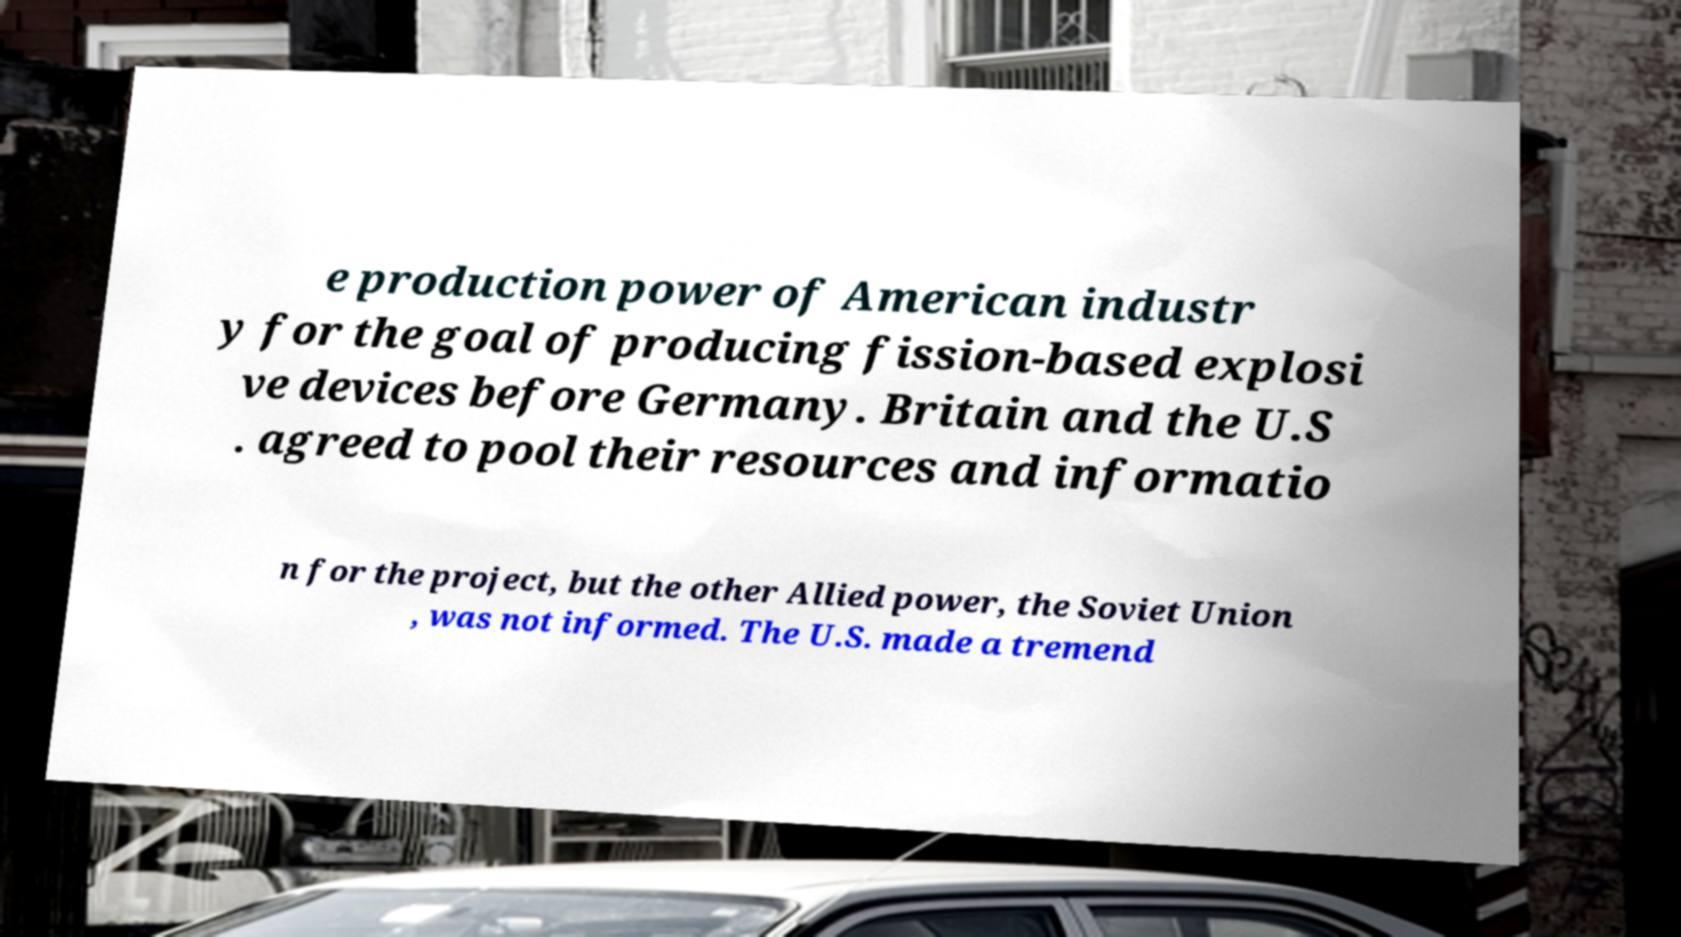Could you extract and type out the text from this image? e production power of American industr y for the goal of producing fission-based explosi ve devices before Germany. Britain and the U.S . agreed to pool their resources and informatio n for the project, but the other Allied power, the Soviet Union , was not informed. The U.S. made a tremend 